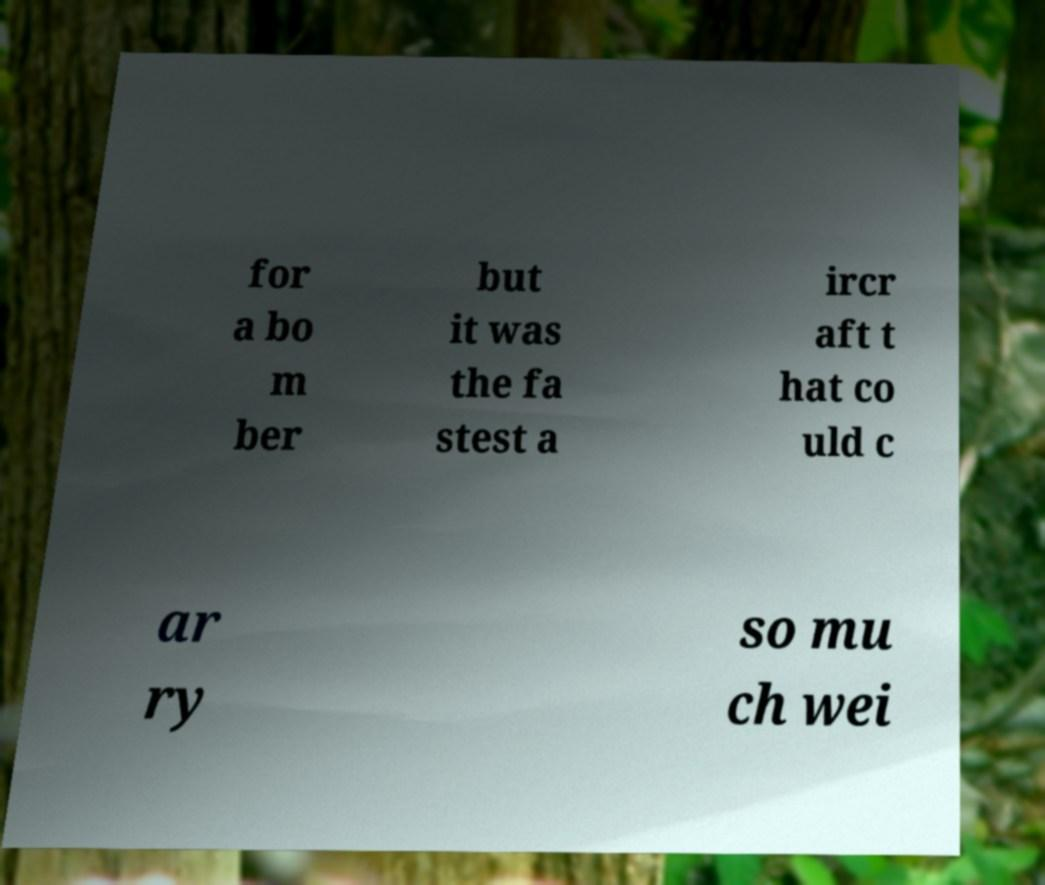I need the written content from this picture converted into text. Can you do that? for a bo m ber but it was the fa stest a ircr aft t hat co uld c ar ry so mu ch wei 